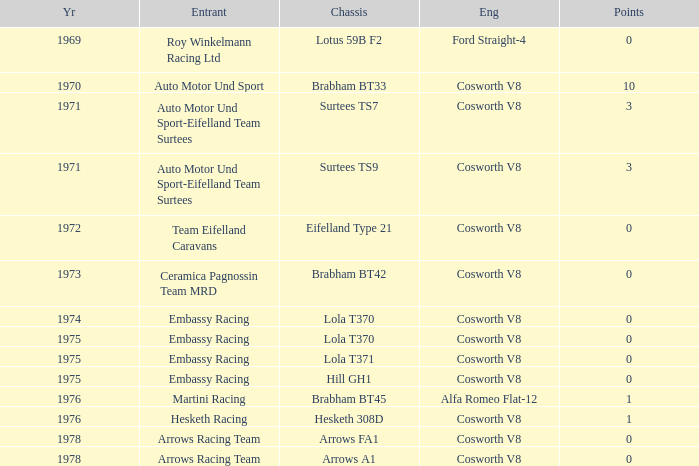What was the total amount of points in 1978 with a Chassis of arrows fa1? 0.0. 